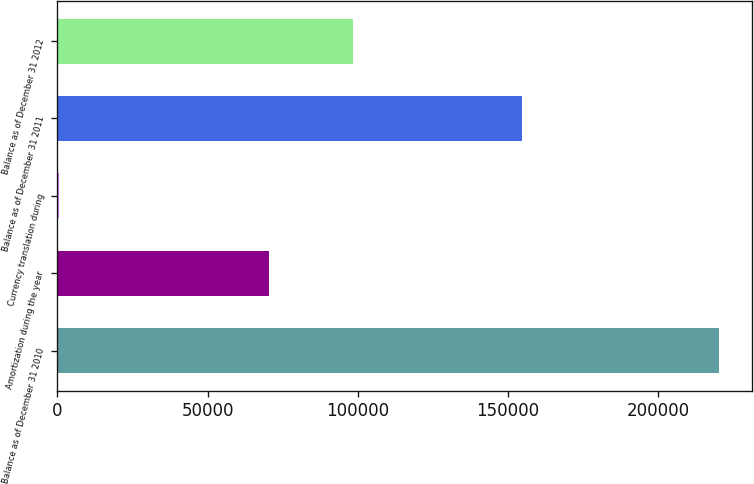Convert chart to OTSL. <chart><loc_0><loc_0><loc_500><loc_500><bar_chart><fcel>Balance as of December 31 2010<fcel>Amortization during the year<fcel>Currency translation during<fcel>Balance as of December 31 2011<fcel>Balance as of December 31 2012<nl><fcel>220237<fcel>70364<fcel>386<fcel>154668<fcel>98296<nl></chart> 